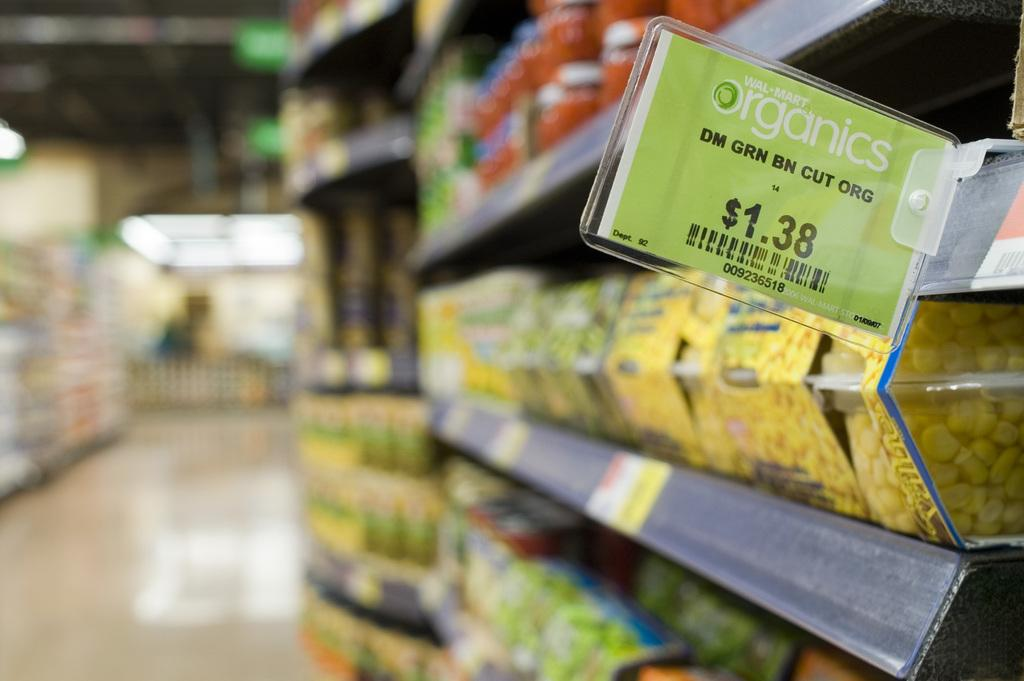<image>
Present a compact description of the photo's key features. the aisle of a organics supermarket that is selling corn in plastic cups. 